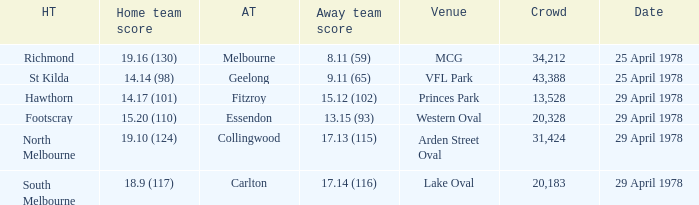What was the away team that played at Princes Park? Fitzroy. 